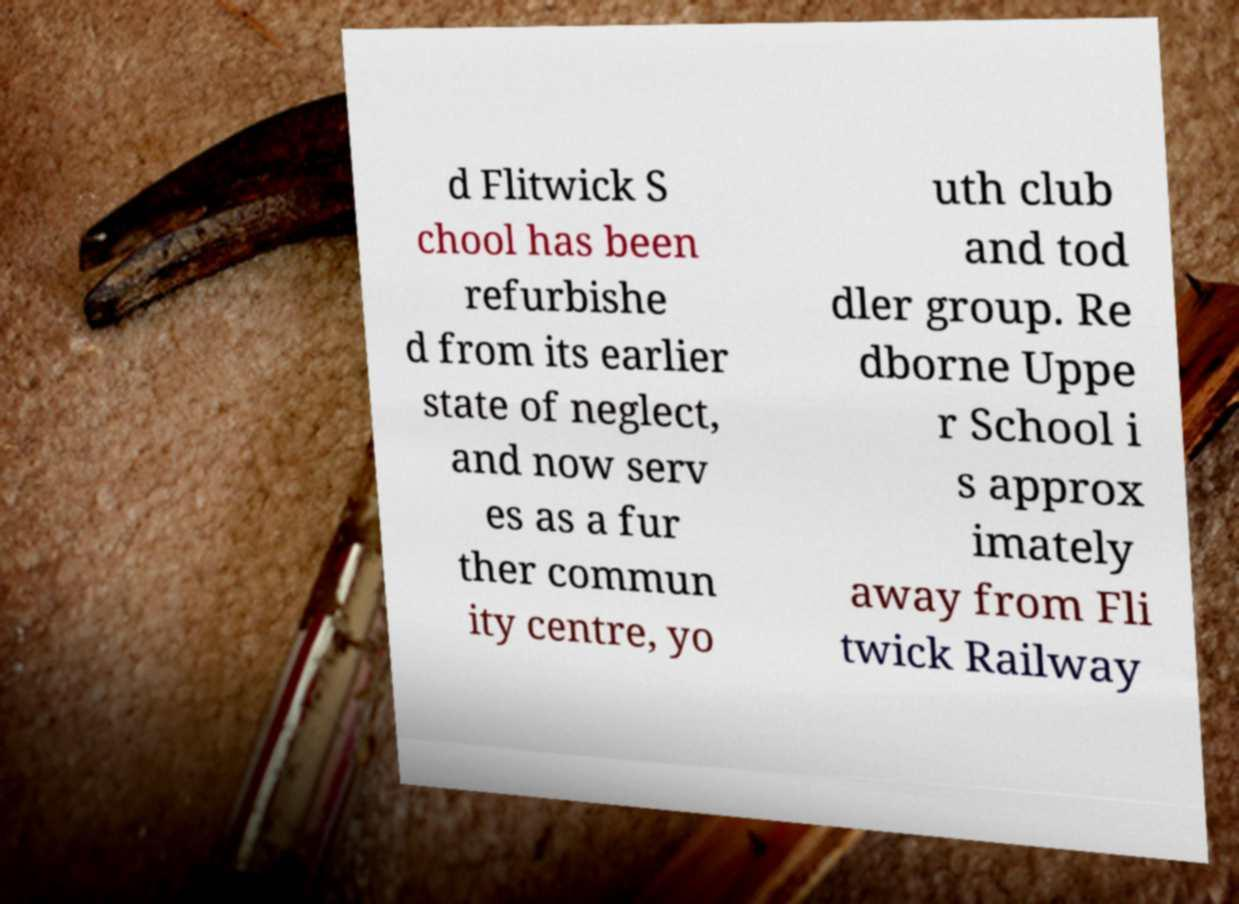I need the written content from this picture converted into text. Can you do that? d Flitwick S chool has been refurbishe d from its earlier state of neglect, and now serv es as a fur ther commun ity centre, yo uth club and tod dler group. Re dborne Uppe r School i s approx imately away from Fli twick Railway 